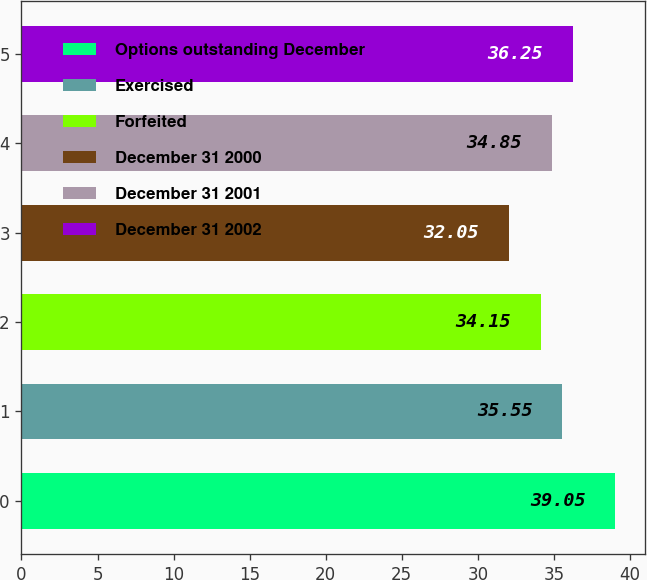<chart> <loc_0><loc_0><loc_500><loc_500><bar_chart><fcel>Options outstanding December<fcel>Exercised<fcel>Forfeited<fcel>December 31 2000<fcel>December 31 2001<fcel>December 31 2002<nl><fcel>39.05<fcel>35.55<fcel>34.15<fcel>32.05<fcel>34.85<fcel>36.25<nl></chart> 